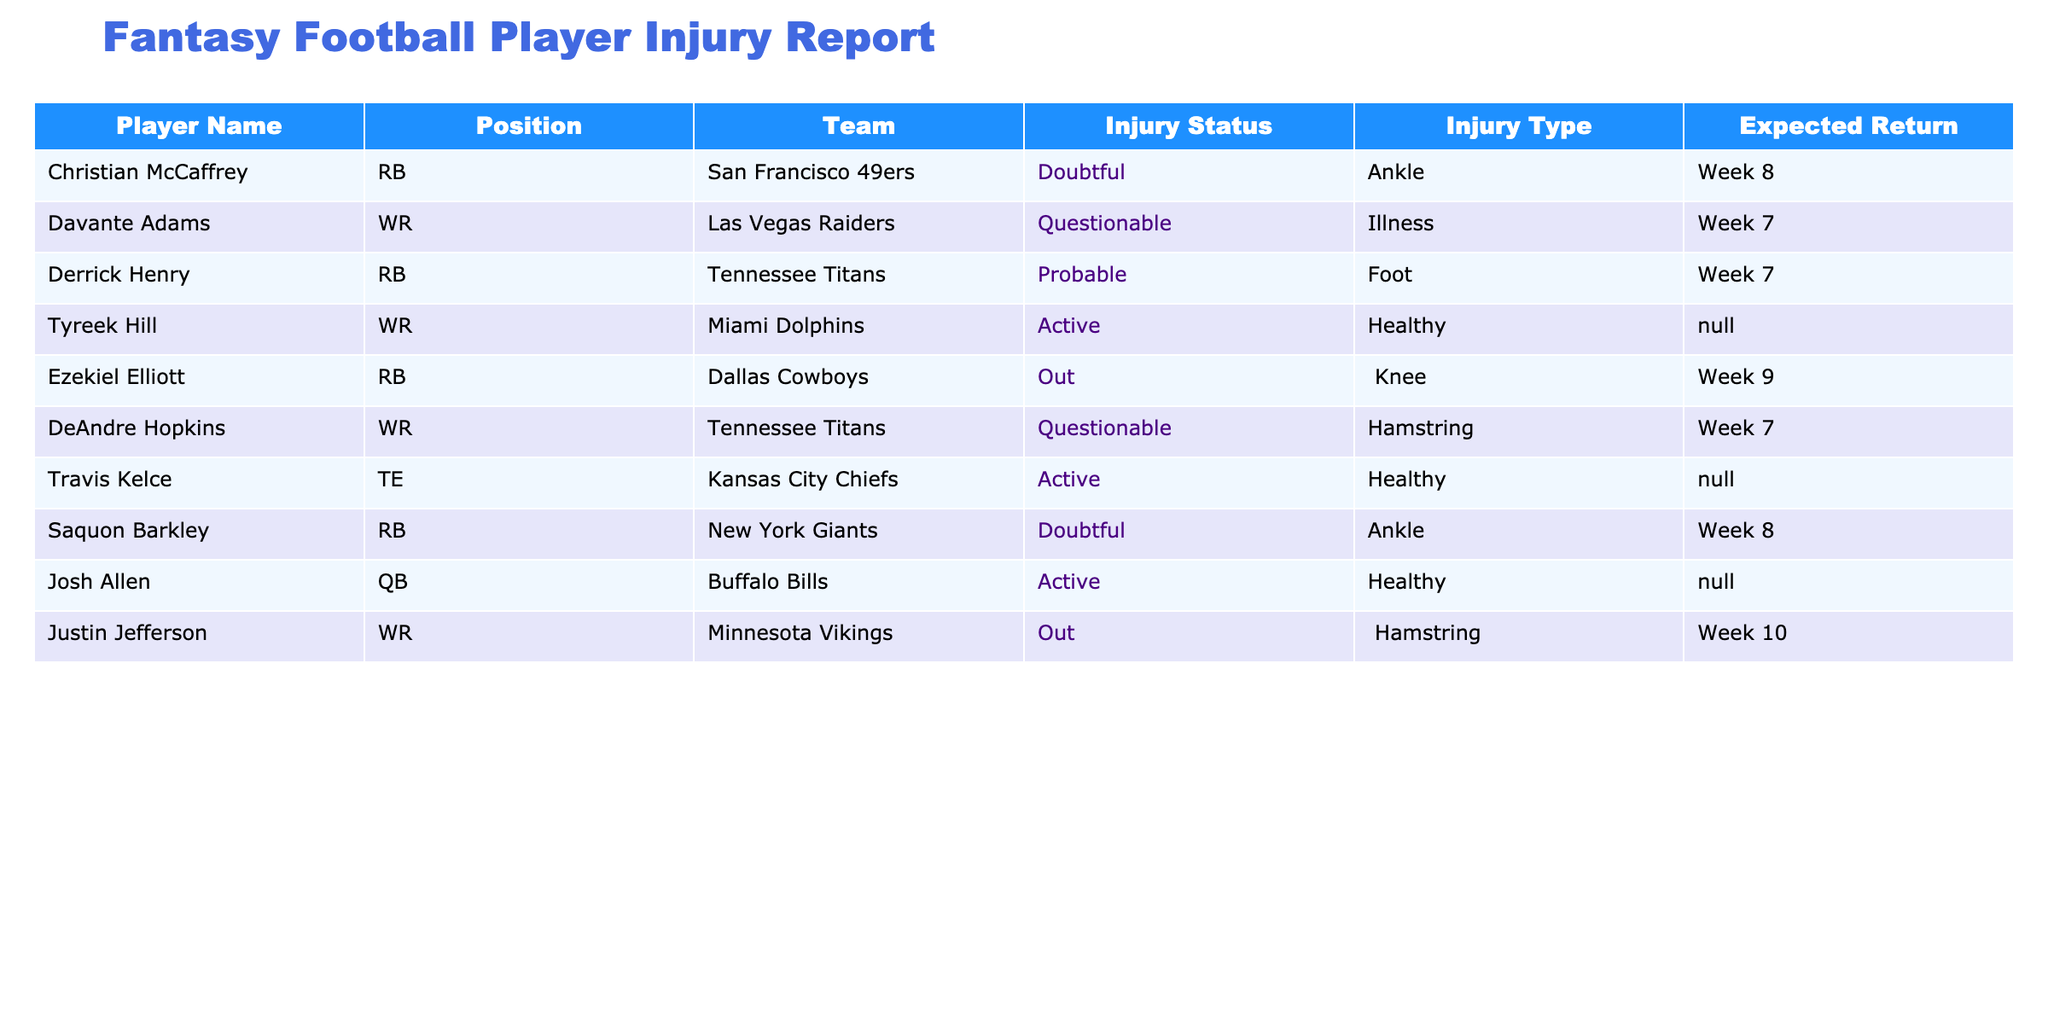What is the expected return of Christian McCaffrey? Christian McCaffrey's injury status is listed as 'Doubtful', and the table states his expected return is in 'Week 8'.
Answer: Week 8 Which player has a foot injury and is probable to play? Derrick Henry is the player noted in the table with a 'Probable' injury status due to a 'Foot' injury.
Answer: Derrick Henry How many players are currently out and what are their names? The table lists Ezekiel Elliott and Justin Jefferson as players with an 'Out' status. There are two players in total.
Answer: 2 players: Ezekiel Elliott and Justin Jefferson Is Tyreek Hill available to play this week? Tyreek Hill has an 'Active' status in the table, indicating that he is available to play.
Answer: Yes What is the injury type for the player expected to return in Week 9? The table states that Ezekiel Elliott is 'Out' with a 'Knee' injury, and he is the only player listed with an expected return in 'Week 9'.
Answer: Knee injury What percentage of the listed players are currently injured? There are 10 players in total in the table, of which 6 are identified as injured. To find the percentage, calculate (6/10)*100 = 60%.
Answer: 60% Which player has a questionable injury status and is expected to return in Week 7? There are two players with 'Questionable' status expected to return in Week 7: Davante Adams and DeAndre Hopkins.
Answer: 2 players: Davante Adams and DeAndre Hopkins What is the average expected return week of the players who are out? The players who are out are Ezekiel Elliott (Week 9) and Justin Jefferson (Week 10). To find the average, convert the weeks to numbers (9 and 10), sum them (9 + 10 = 19), and divide by 2. The average week is 19 / 2 = 9.5. Therefore, round it to 10.
Answer: Week 10 How many players are active and healthy according to the injury report? The active players listed in the report are Tyreek Hill, Travis Kelce, and Josh Allen. There are three players marked as active and healthy.
Answer: 3 players 